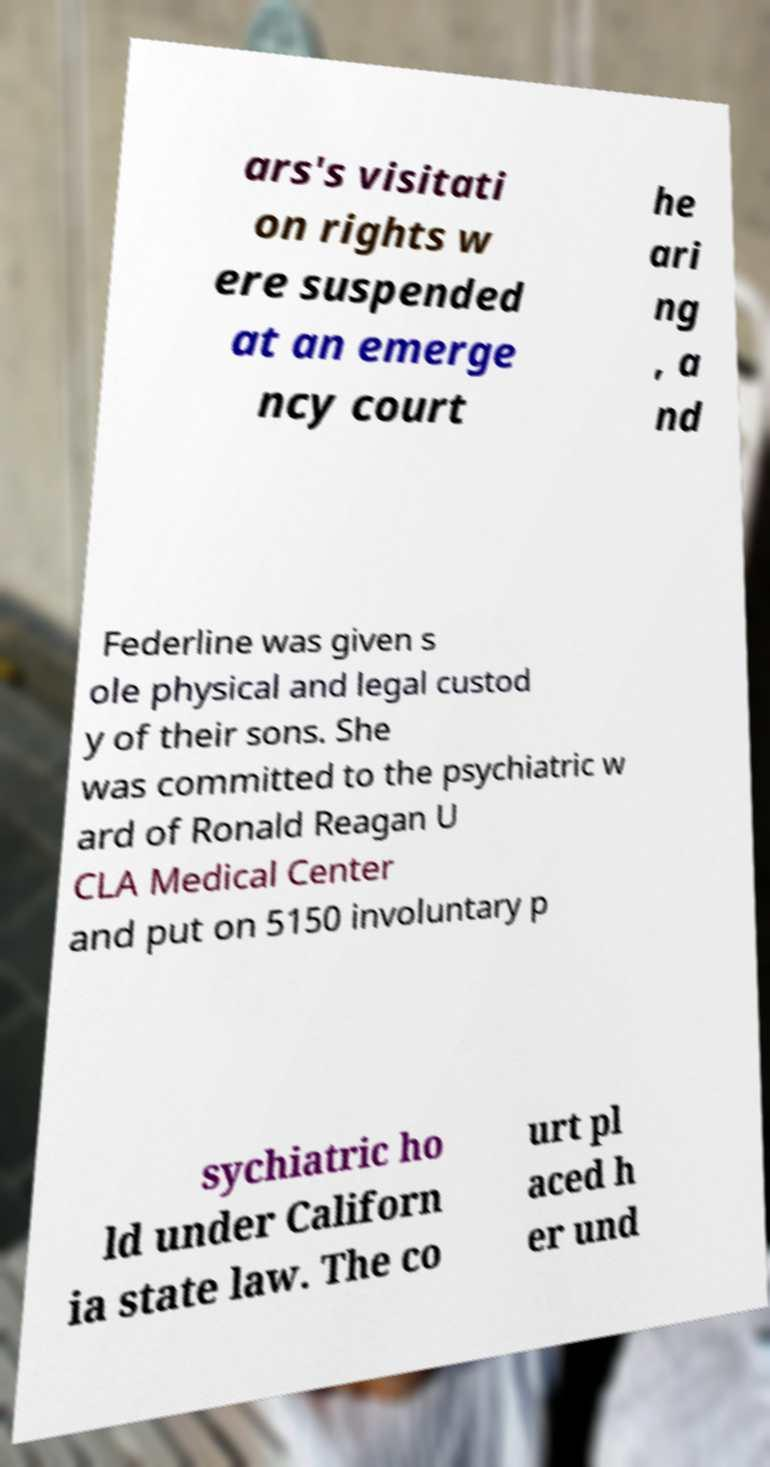Can you read and provide the text displayed in the image?This photo seems to have some interesting text. Can you extract and type it out for me? ars's visitati on rights w ere suspended at an emerge ncy court he ari ng , a nd Federline was given s ole physical and legal custod y of their sons. She was committed to the psychiatric w ard of Ronald Reagan U CLA Medical Center and put on 5150 involuntary p sychiatric ho ld under Californ ia state law. The co urt pl aced h er und 